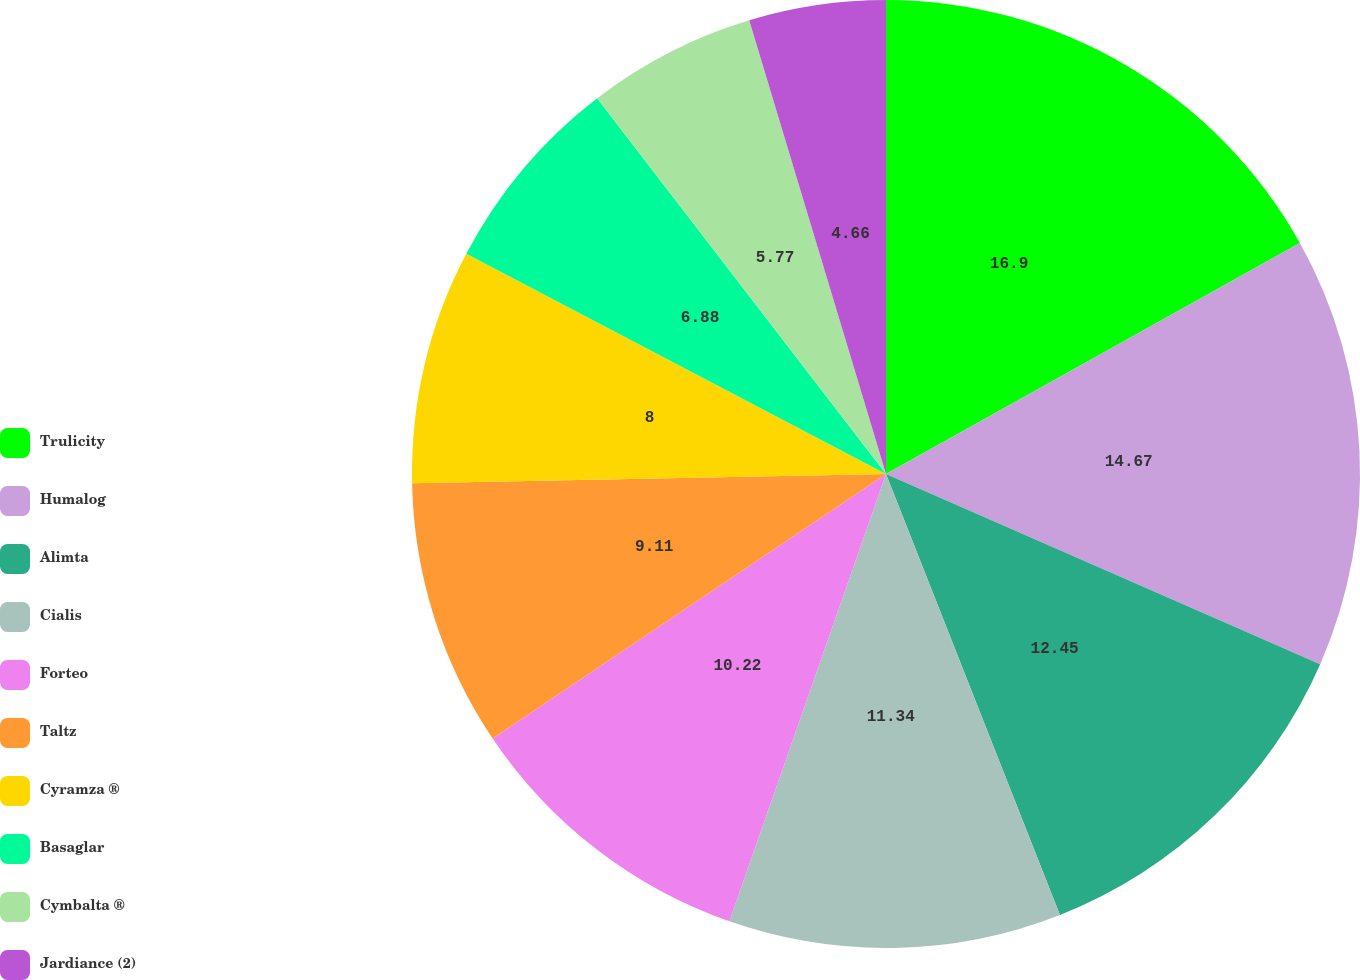Convert chart. <chart><loc_0><loc_0><loc_500><loc_500><pie_chart><fcel>Trulicity<fcel>Humalog<fcel>Alimta<fcel>Cialis<fcel>Forteo<fcel>Taltz<fcel>Cyramza ®<fcel>Basaglar<fcel>Cymbalta ®<fcel>Jardiance (2)<nl><fcel>16.9%<fcel>14.67%<fcel>12.45%<fcel>11.34%<fcel>10.22%<fcel>9.11%<fcel>8.0%<fcel>6.88%<fcel>5.77%<fcel>4.66%<nl></chart> 